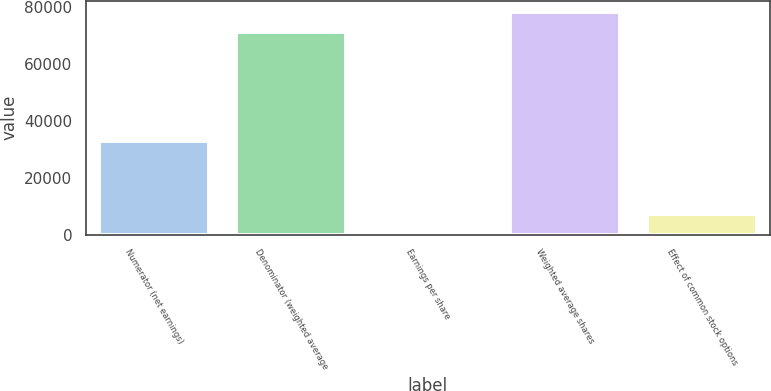Convert chart to OTSL. <chart><loc_0><loc_0><loc_500><loc_500><bar_chart><fcel>Numerator (net earnings)<fcel>Denominator (weighted average<fcel>Earnings per share<fcel>Weighted average shares<fcel>Effect of common stock options<nl><fcel>32945<fcel>71204<fcel>0.46<fcel>78324.4<fcel>7120.81<nl></chart> 